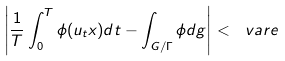Convert formula to latex. <formula><loc_0><loc_0><loc_500><loc_500>\left | \frac { 1 } { T } \int _ { 0 } ^ { T } \phi ( u _ { t } x ) d t - \int _ { G / \Gamma } \phi d g \right | < \ v a r e</formula> 